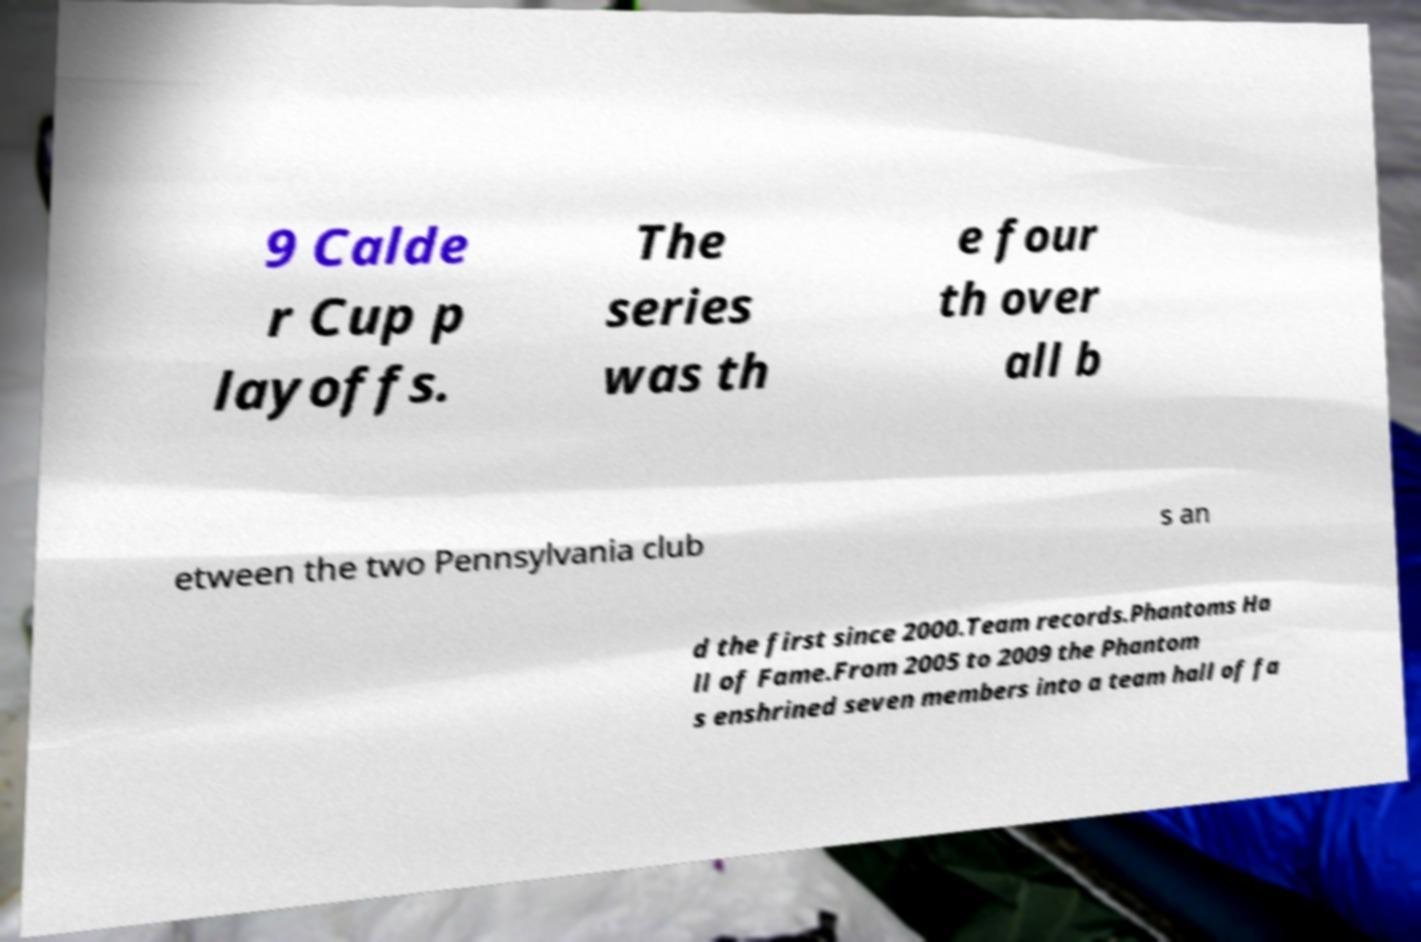Could you assist in decoding the text presented in this image and type it out clearly? 9 Calde r Cup p layoffs. The series was th e four th over all b etween the two Pennsylvania club s an d the first since 2000.Team records.Phantoms Ha ll of Fame.From 2005 to 2009 the Phantom s enshrined seven members into a team hall of fa 